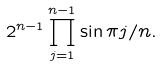Convert formula to latex. <formula><loc_0><loc_0><loc_500><loc_500>2 ^ { n - 1 } \prod _ { j = 1 } ^ { n - 1 } \sin \pi j / n .</formula> 